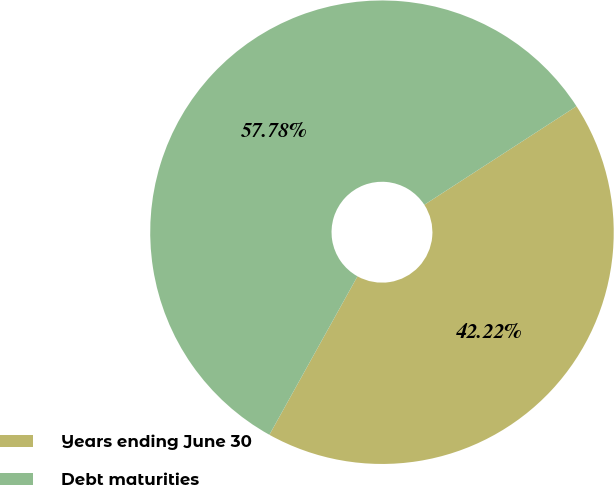<chart> <loc_0><loc_0><loc_500><loc_500><pie_chart><fcel>Years ending June 30<fcel>Debt maturities<nl><fcel>42.22%<fcel>57.78%<nl></chart> 